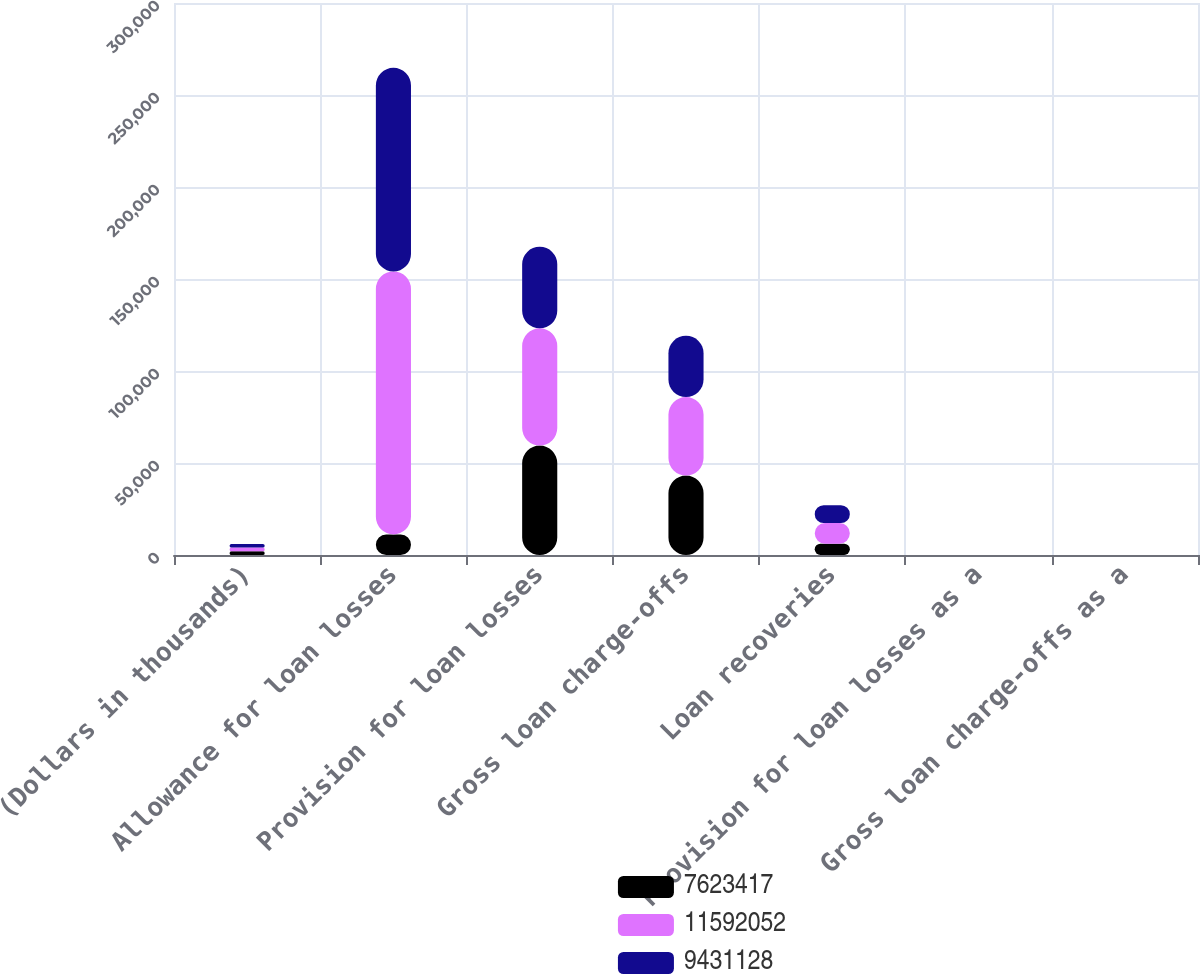Convert chart to OTSL. <chart><loc_0><loc_0><loc_500><loc_500><stacked_bar_chart><ecel><fcel>(Dollars in thousands)<fcel>Allowance for loan losses<fcel>Provision for loan losses<fcel>Gross loan charge-offs<fcel>Loan recoveries<fcel>Provision for loan losses as a<fcel>Gross loan charge-offs as a<nl><fcel>7.62342e+06<fcel>2014<fcel>11208<fcel>59486<fcel>43168<fcel>6155<fcel>0.41<fcel>0.37<nl><fcel>1.15921e+07<fcel>2013<fcel>142886<fcel>63693<fcel>42666<fcel>11208<fcel>0.58<fcel>0.45<nl><fcel>9.43113e+06<fcel>2012<fcel>110651<fcel>44330<fcel>33319<fcel>9693<fcel>0.49<fcel>0.44<nl></chart> 